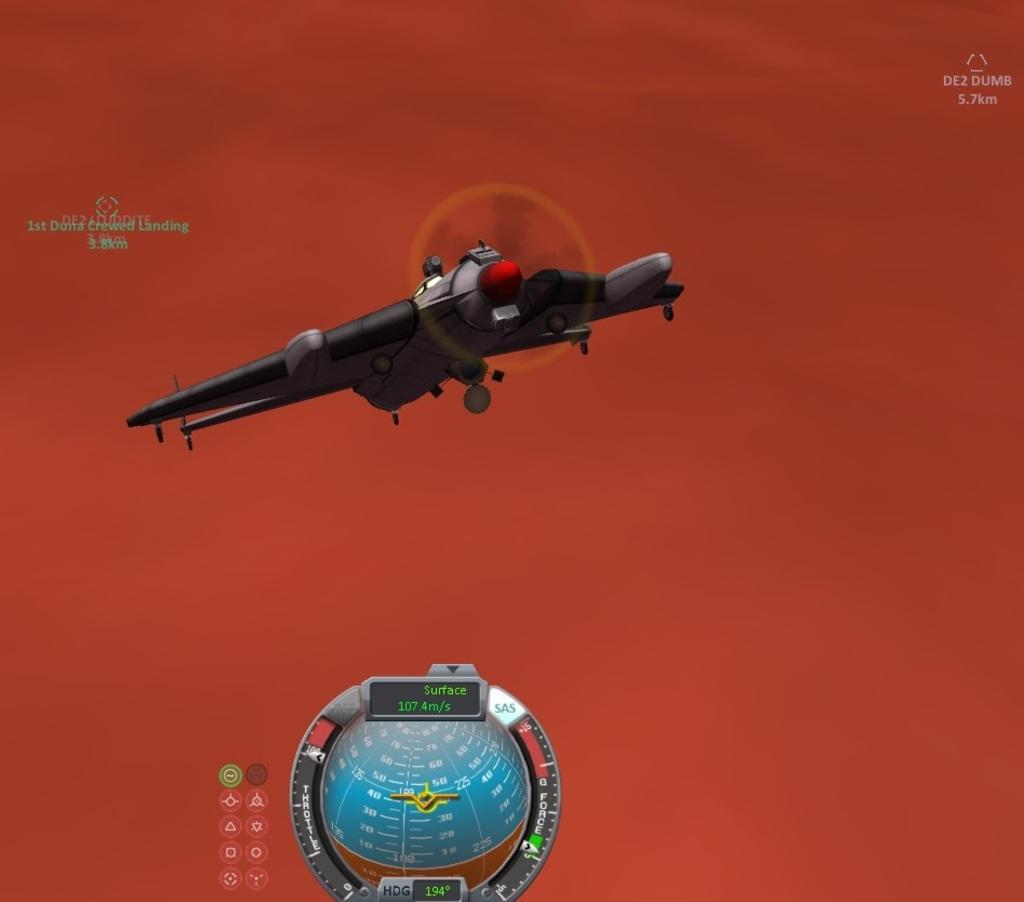What type of aircraft is depicted in the image? There is an animated aircraft in the image. What other object can be seen in the image? There is a globe in the image. What is the background color of the image? The background color of the image is red. What else is featured in the image besides the aircraft and globe? There is text and sign images in the image. How much glue is needed to attach the aircraft to the globe in the image? There is no glue present in the image, and the aircraft and globe are not depicted as being attached to each other. What is the rate of the aircraft's movement in the image? The aircraft is animated, but there is no indication of its movement rate in the image. 